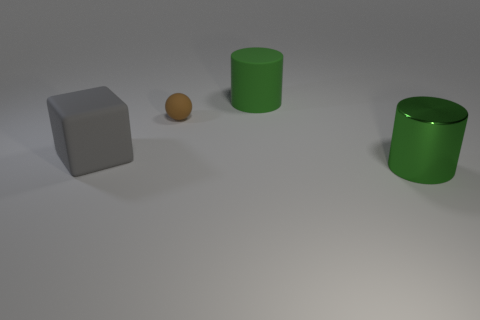The other small object that is made of the same material as the gray object is what shape?
Provide a succinct answer. Sphere. Are there more tiny brown matte balls that are in front of the brown matte thing than large purple rubber objects?
Make the answer very short. No. How many matte things have the same color as the large metallic thing?
Offer a terse response. 1. How many other objects are there of the same color as the tiny matte sphere?
Give a very brief answer. 0. Is the number of brown objects greater than the number of green cylinders?
Make the answer very short. No. What is the material of the large gray cube?
Your answer should be compact. Rubber. There is a thing behind the brown ball; is it the same size as the small brown ball?
Ensure brevity in your answer.  No. There is a thing that is behind the small brown rubber sphere; what size is it?
Provide a succinct answer. Large. Is there anything else that is made of the same material as the block?
Offer a very short reply. Yes. What number of rubber cubes are there?
Your answer should be very brief. 1. 